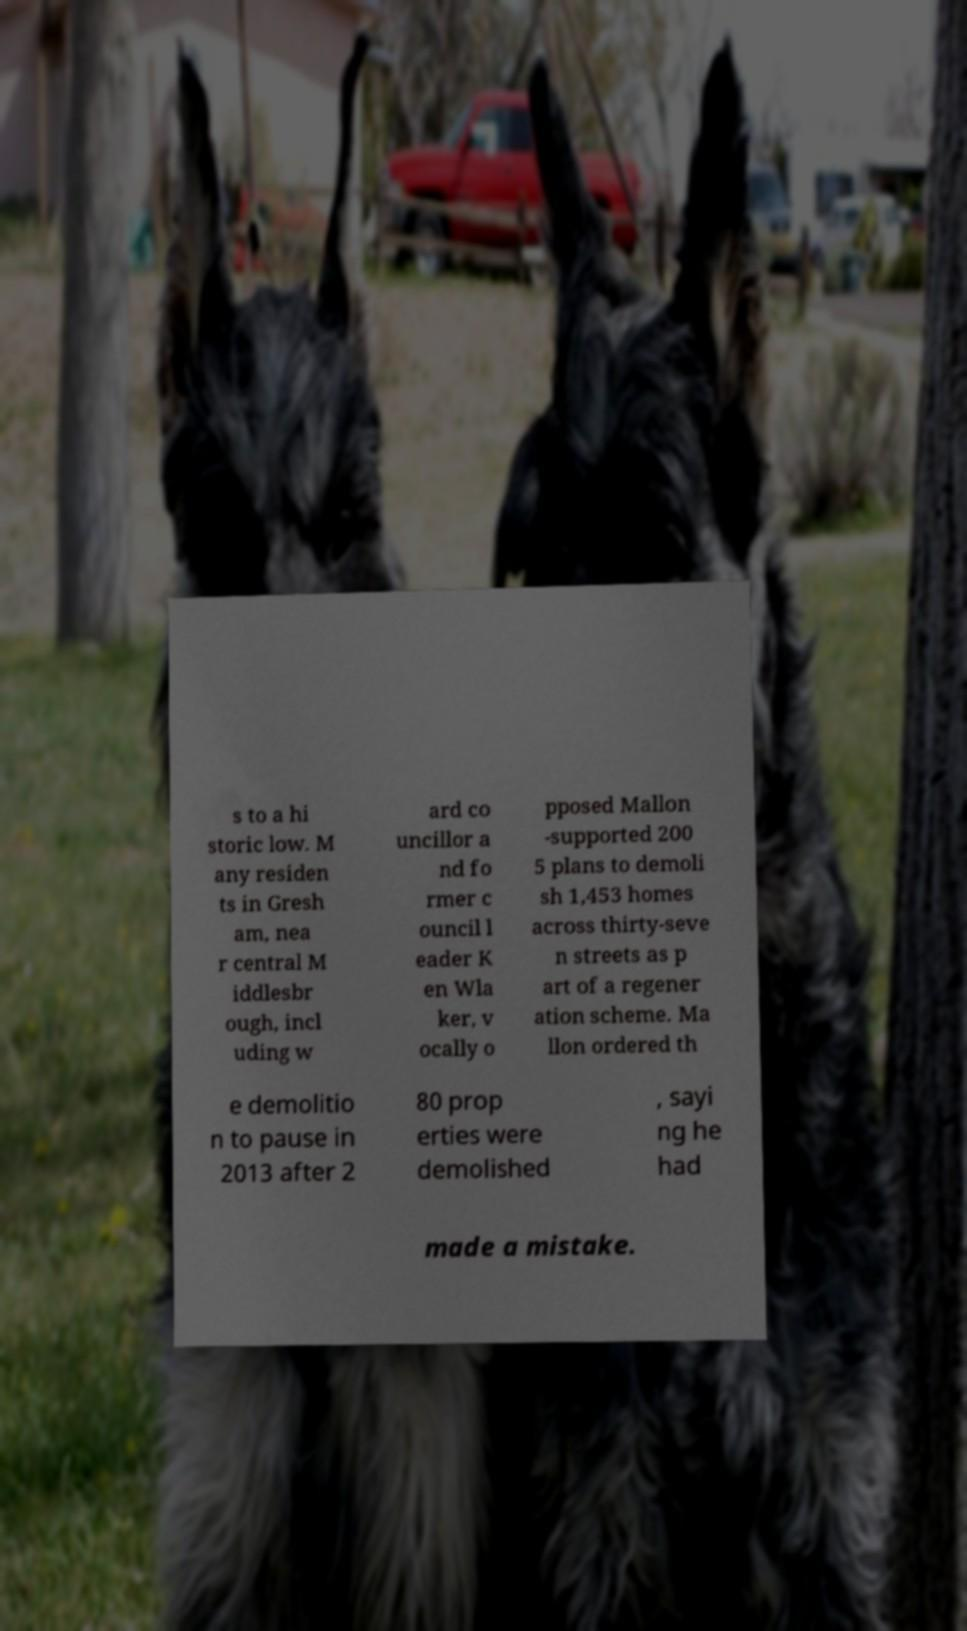What messages or text are displayed in this image? I need them in a readable, typed format. s to a hi storic low. M any residen ts in Gresh am, nea r central M iddlesbr ough, incl uding w ard co uncillor a nd fo rmer c ouncil l eader K en Wla ker, v ocally o pposed Mallon -supported 200 5 plans to demoli sh 1,453 homes across thirty-seve n streets as p art of a regener ation scheme. Ma llon ordered th e demolitio n to pause in 2013 after 2 80 prop erties were demolished , sayi ng he had made a mistake. 